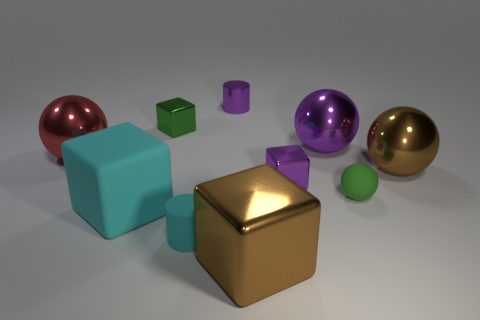How many large red things are made of the same material as the small cyan cylinder?
Your response must be concise. 0. How many things are either big metallic balls that are right of the small cyan rubber thing or tiny objects behind the tiny green matte ball?
Make the answer very short. 5. Is the number of tiny matte cylinders that are behind the green sphere greater than the number of matte balls on the left side of the cyan cylinder?
Provide a short and direct response. No. What color is the small shiny thing in front of the purple ball?
Provide a short and direct response. Purple. Is there a purple thing of the same shape as the large cyan rubber object?
Provide a succinct answer. Yes. What number of purple objects are either large spheres or cylinders?
Your answer should be compact. 2. Are there any cyan rubber objects that have the same size as the purple shiny cube?
Provide a succinct answer. Yes. How many small brown rubber cylinders are there?
Keep it short and to the point. 0. How many small things are brown metallic blocks or matte cubes?
Offer a very short reply. 0. The small cylinder that is in front of the tiny metallic thing left of the purple shiny thing behind the green shiny block is what color?
Offer a terse response. Cyan. 